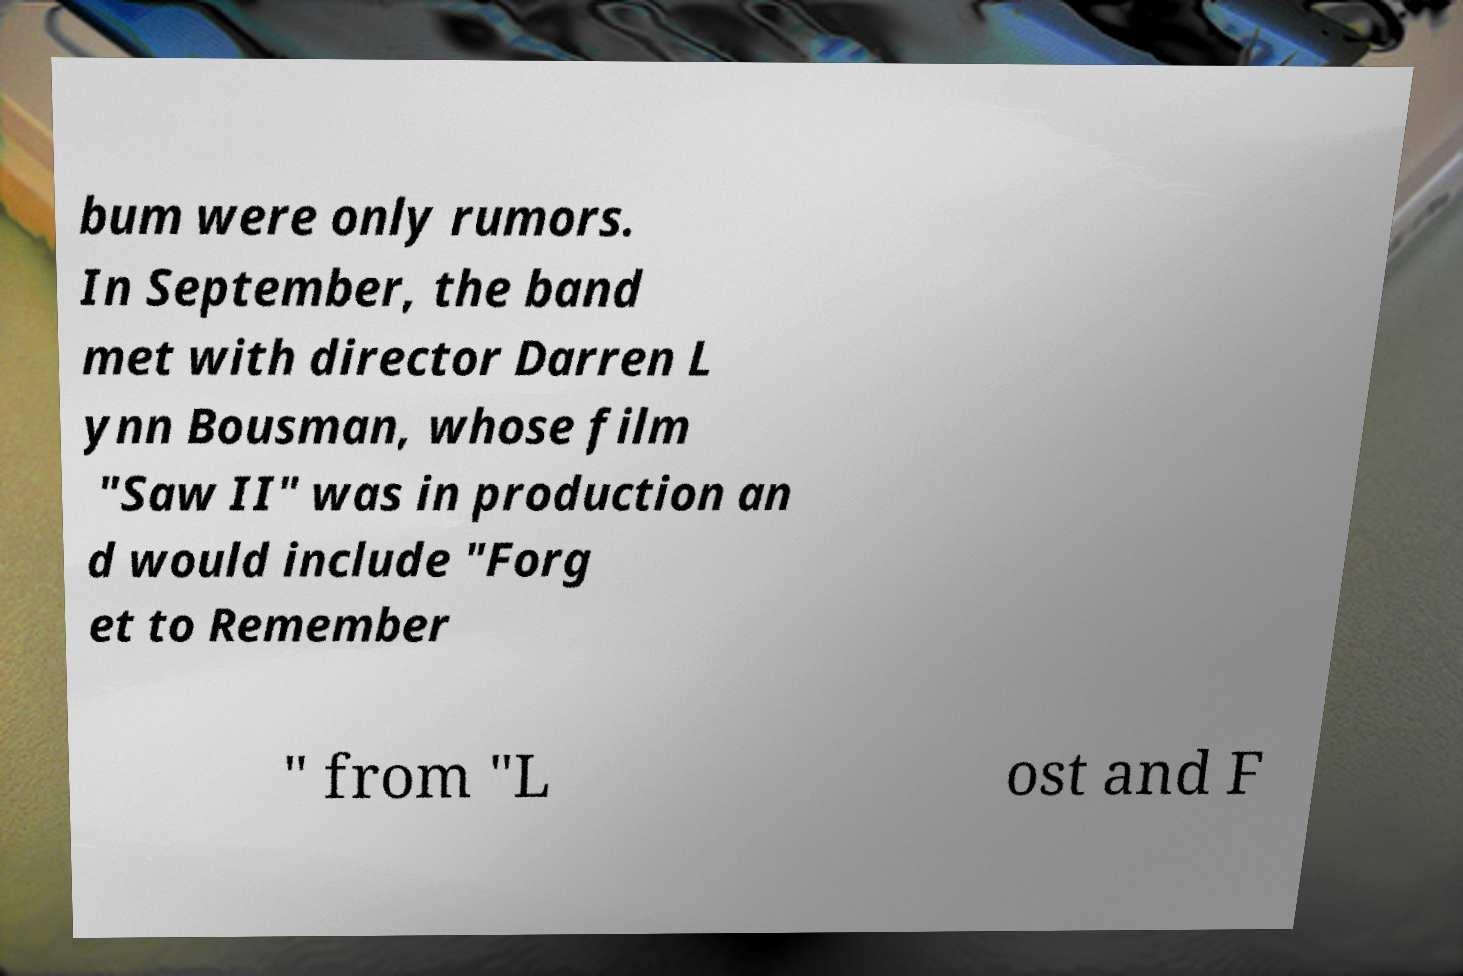I need the written content from this picture converted into text. Can you do that? bum were only rumors. In September, the band met with director Darren L ynn Bousman, whose film "Saw II" was in production an d would include "Forg et to Remember " from "L ost and F 